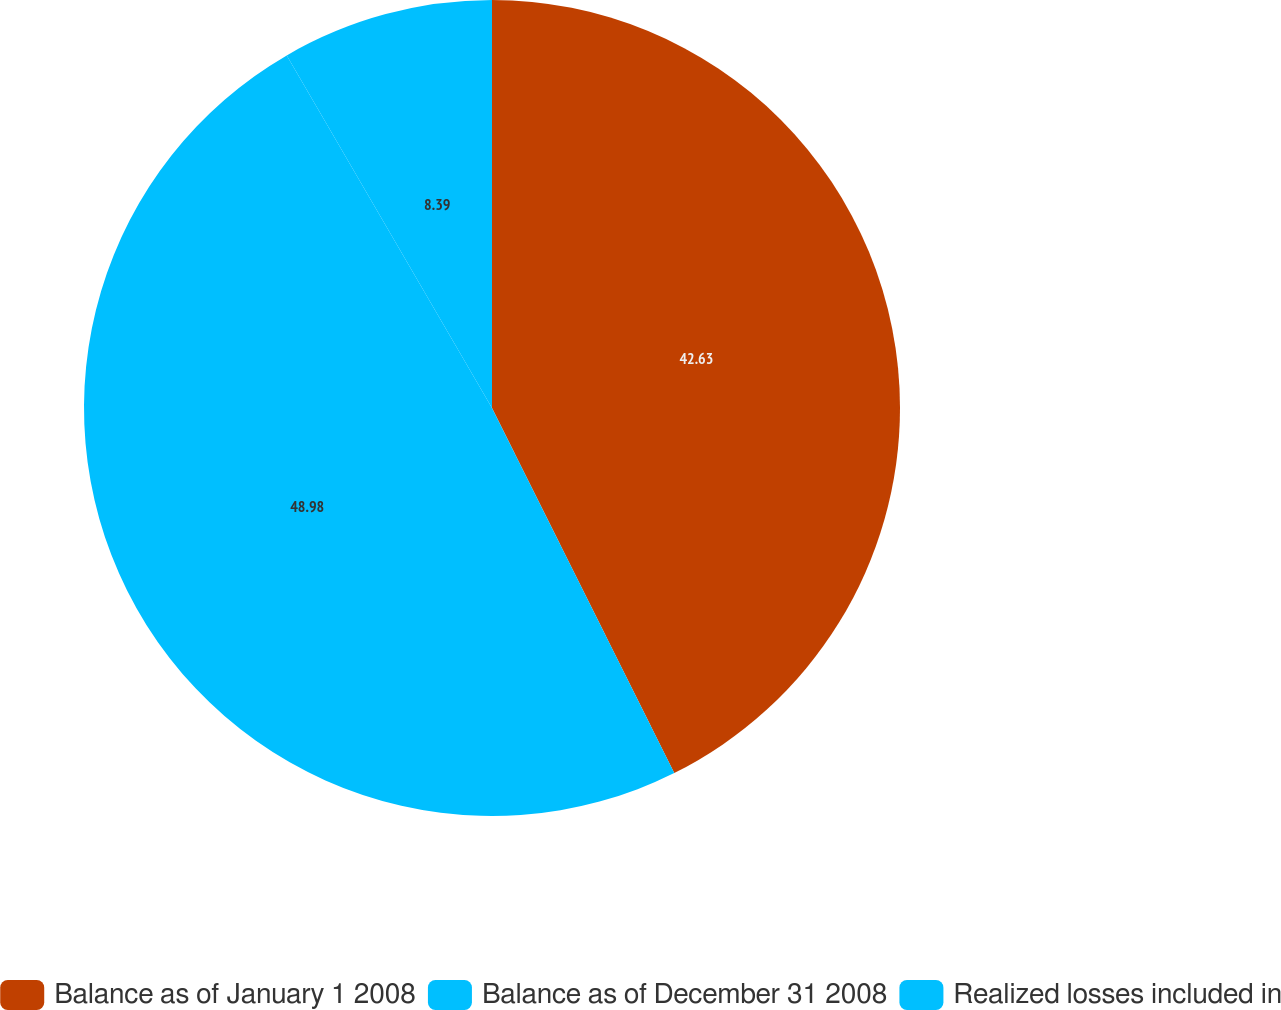<chart> <loc_0><loc_0><loc_500><loc_500><pie_chart><fcel>Balance as of January 1 2008<fcel>Balance as of December 31 2008<fcel>Realized losses included in<nl><fcel>42.63%<fcel>48.98%<fcel>8.39%<nl></chart> 